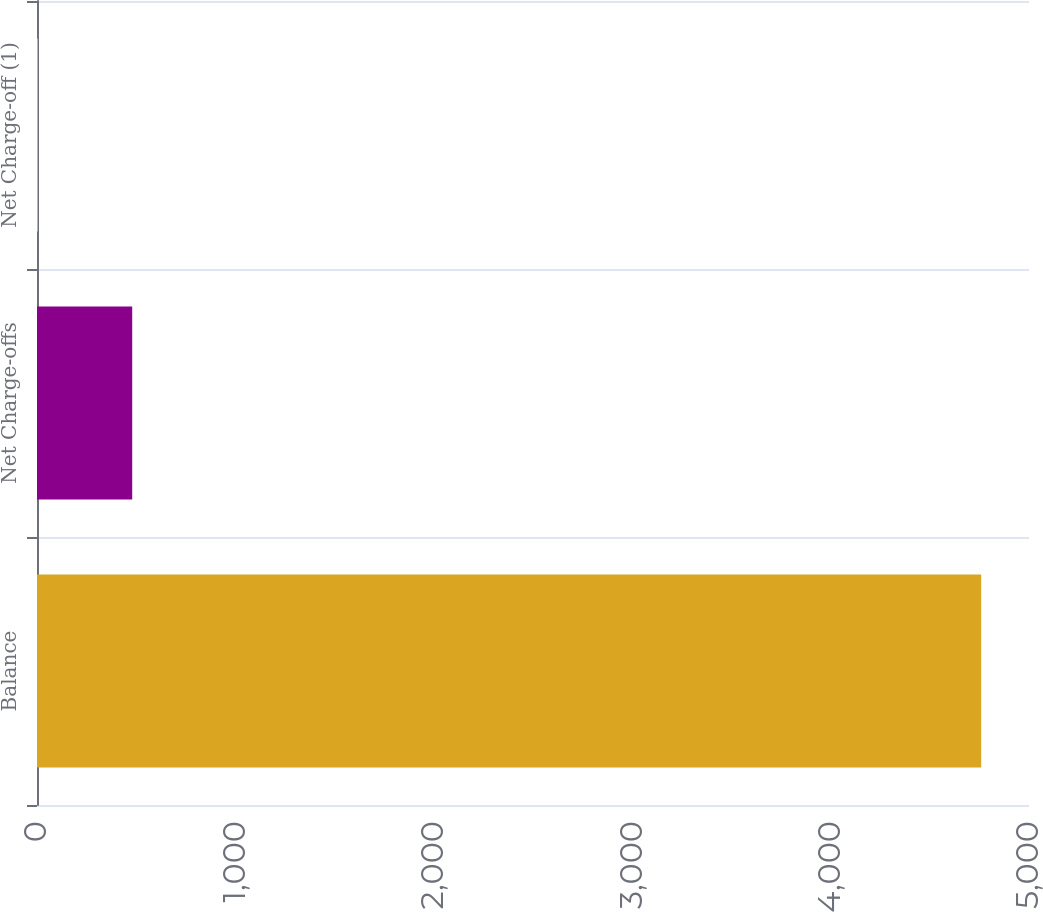Convert chart to OTSL. <chart><loc_0><loc_0><loc_500><loc_500><bar_chart><fcel>Balance<fcel>Net Charge-offs<fcel>Net Charge-off (1)<nl><fcel>4759<fcel>479.9<fcel>4.44<nl></chart> 